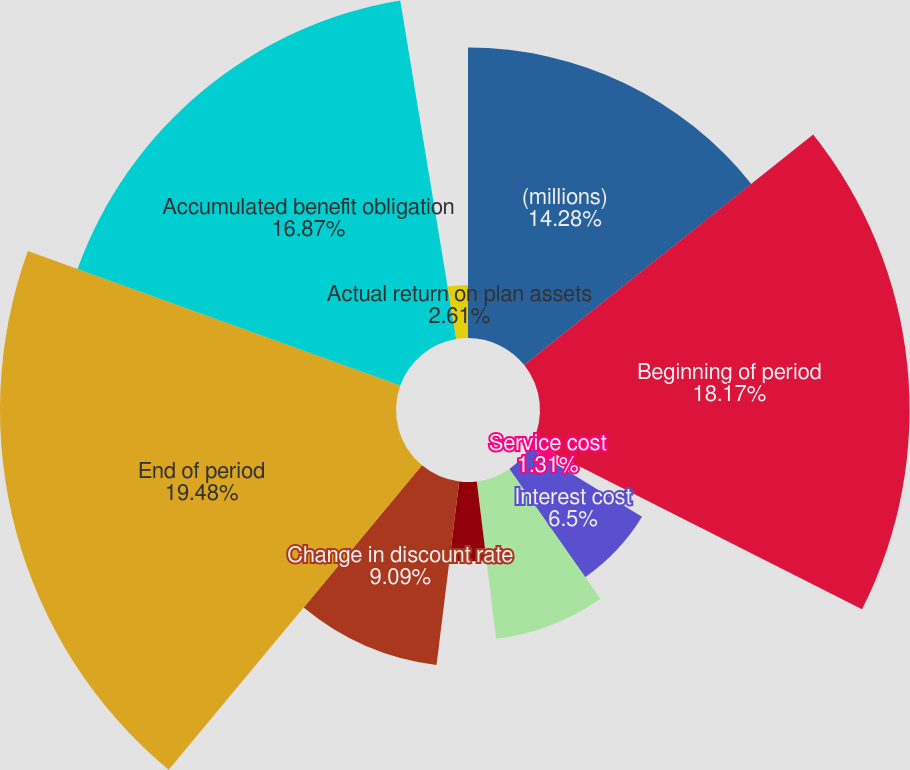Convert chart to OTSL. <chart><loc_0><loc_0><loc_500><loc_500><pie_chart><fcel>(millions)<fcel>Beginning of period<fcel>Service cost<fcel>Interest cost<fcel>Actuarial loss<fcel>Benefit payments<fcel>Change in discount rate<fcel>End of period<fcel>Accumulated benefit obligation<fcel>Actual return on plan assets<nl><fcel>14.28%<fcel>18.17%<fcel>1.31%<fcel>6.5%<fcel>7.79%<fcel>3.9%<fcel>9.09%<fcel>19.47%<fcel>16.87%<fcel>2.61%<nl></chart> 